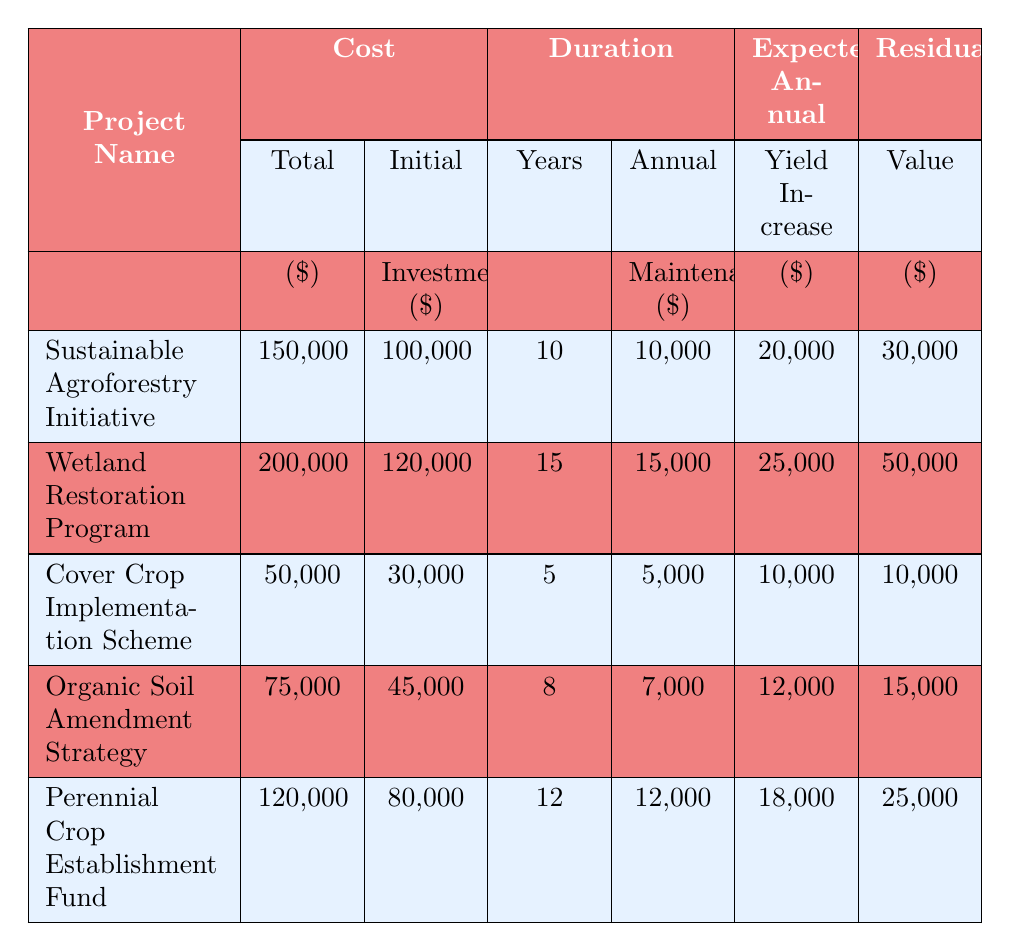What is the total cost of the Wetland Restoration Program? The total cost for the Wetland Restoration Program is listed in the "Cost" section of the table. It shows 200,000 for this project.
Answer: 200,000 What is the expected annual yield increase for the Sustainable Agroforestry Initiative? To find this, locate the row for the Sustainable Agroforestry Initiative and look under the "Expected Annual Yield Increase" column, which shows 20,000.
Answer: 20,000 Which project has the longest duration? The duration can be compared across all projects. The Wetland Restoration Program has a duration of 15 years, which is the highest among listed projects.
Answer: Wetland Restoration Program Is the initial investment for the Cover Crop Implementation Scheme lower than $40,000? Check the initial investment for the Cover Crop Implementation Scheme, which is shown as 30,000; since 30,000 is lower than 40,000, the statement is true.
Answer: Yes What is the average annual maintenance cost of all projects combined? To calculate the average annual maintenance cost, sum all projects' maintenance costs (10,000 + 15,000 + 5,000 + 7,000 + 12,000 = 49,000) and divide by the number of projects (5). The average is 49,000 / 5 = 9,800.
Answer: 9,800 Which project has the highest total cost and what is that cost? Review the total cost column across projects. The Wetland Restoration Program has the highest total cost of 200,000.
Answer: 200,000 Is it true that the Perennial Crop Establishment Fund has a higher expected annual yield increase than the Organic Soil Amendment Strategy? Compare the expected annual yield increase values for both projects; the Perennial Crop Establishment Fund is 18,000 and the Organic Soil Amendment Strategy is 12,000. Since 18,000 is greater than 12,000, the statement is true.
Answer: Yes What is the difference between the total costs of the Sustainable Agroforestry Initiative and the Cover Crop Implementation Scheme? Subtract the total cost of the Cover Crop Implementation Scheme (50,000) from the total cost of the Sustainable Agroforestry Initiative (150,000). The difference is 150,000 - 50,000 = 100,000.
Answer: 100,000 What is the residual value for the Organic Soil Amendment Strategy? Look at the residual value column for the Organic Soil Amendment Strategy, which indicates a value of 15,000.
Answer: 15,000 